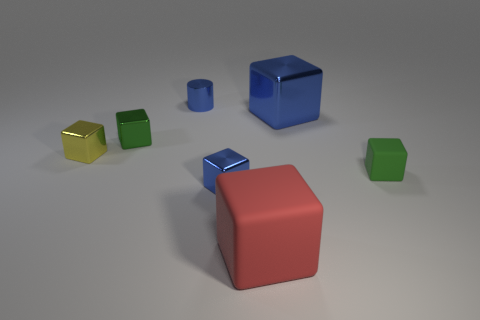What number of things have the same color as the small cylinder?
Give a very brief answer. 2. There is a cylinder that is made of the same material as the tiny yellow cube; what is its size?
Your answer should be very brief. Small. What number of yellow things are small cubes or large blocks?
Offer a very short reply. 1. What number of big cubes are behind the big block that is in front of the yellow metallic block?
Provide a succinct answer. 1. Are there more big blue blocks behind the tiny green rubber object than tiny blue metallic cylinders on the left side of the yellow block?
Offer a terse response. Yes. What is the material of the large blue cube?
Provide a succinct answer. Metal. Are there any green metallic cylinders that have the same size as the green matte thing?
Your response must be concise. No. What material is the blue cube that is the same size as the red rubber object?
Ensure brevity in your answer.  Metal. How many green rubber cubes are there?
Offer a terse response. 1. There is a green thing right of the red rubber thing; how big is it?
Ensure brevity in your answer.  Small. 